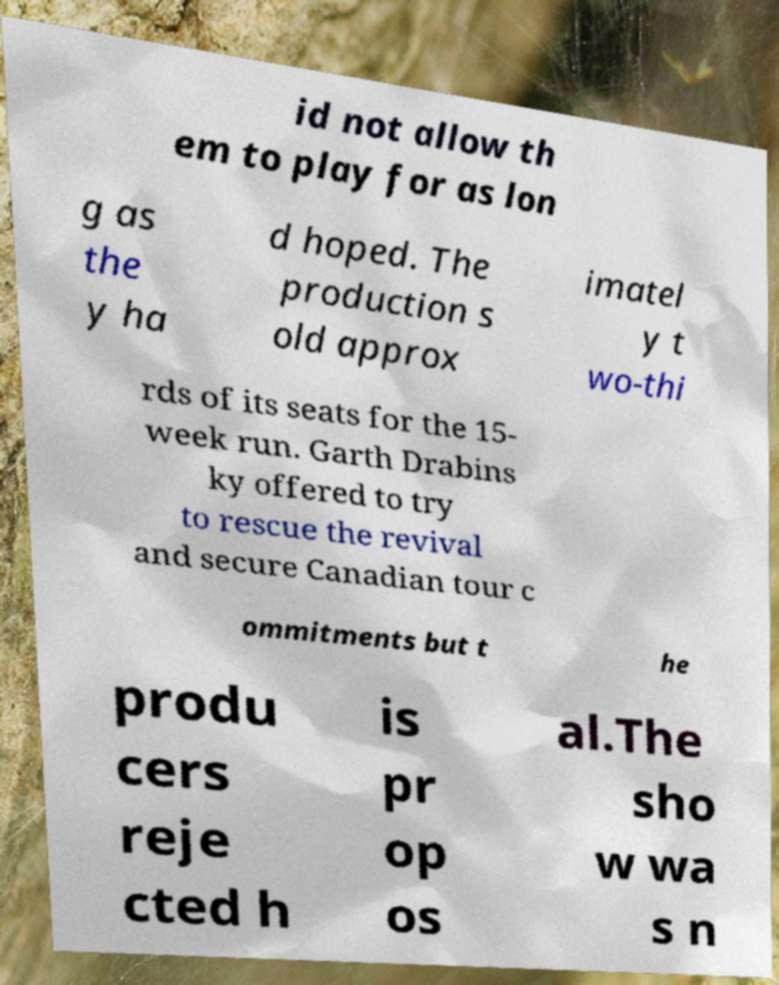Could you extract and type out the text from this image? id not allow th em to play for as lon g as the y ha d hoped. The production s old approx imatel y t wo-thi rds of its seats for the 15- week run. Garth Drabins ky offered to try to rescue the revival and secure Canadian tour c ommitments but t he produ cers reje cted h is pr op os al.The sho w wa s n 